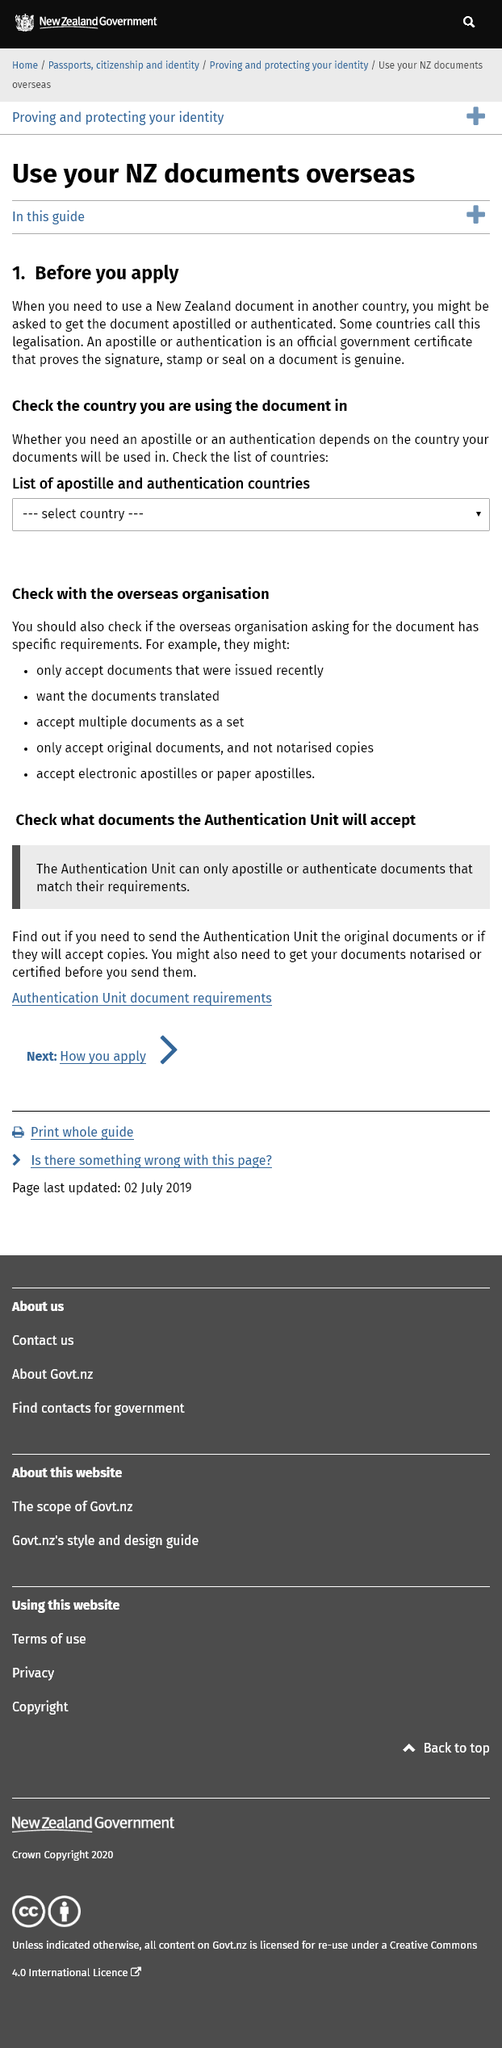Specify some key components in this picture. When requesting a document from an overseas organization, it is necessary to verify if it has any specific requirements. It is possible to determine whether an apostille or an authentication is required by consulting a list of countries. An apostille or authentication is a government certificate that proves the signature, stamp or seal on a document is genuine. It is necessary to notarize or certify documents before sending them in order to establish the authenticity and credibility of the information they contain. New Zealand is commonly referred to as NZ, and it is an abbreviation of this name. 